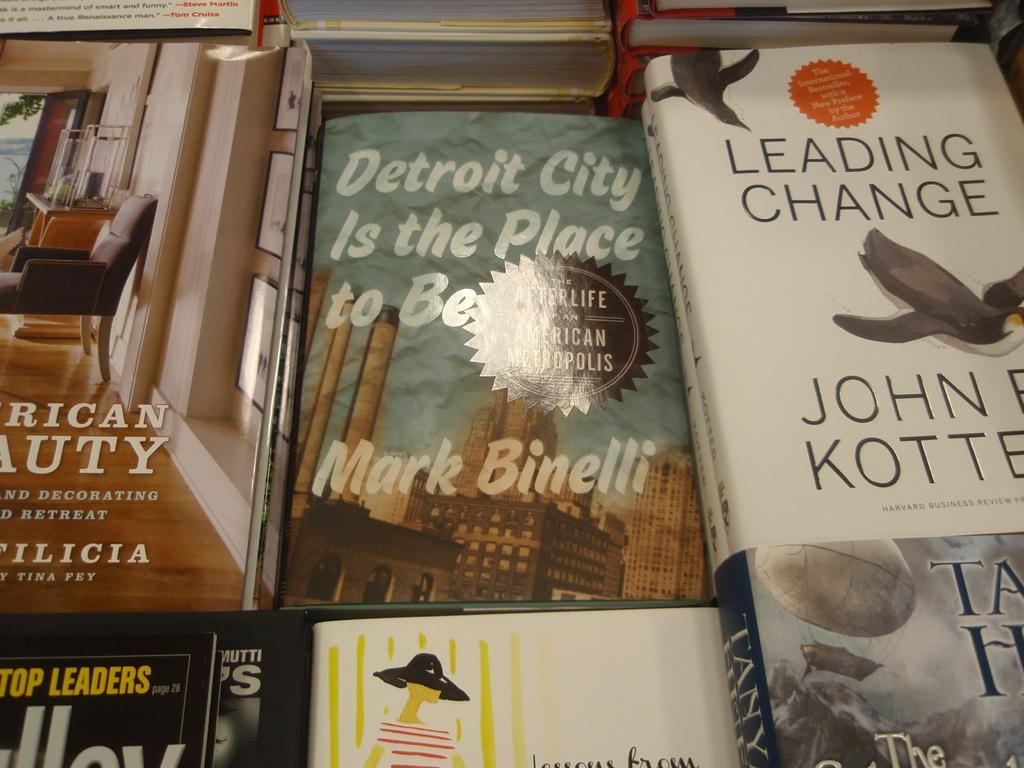<image>
Present a compact description of the photo's key features. A selection of books, including Detroit is the Place to Be by Mark Binelli. 